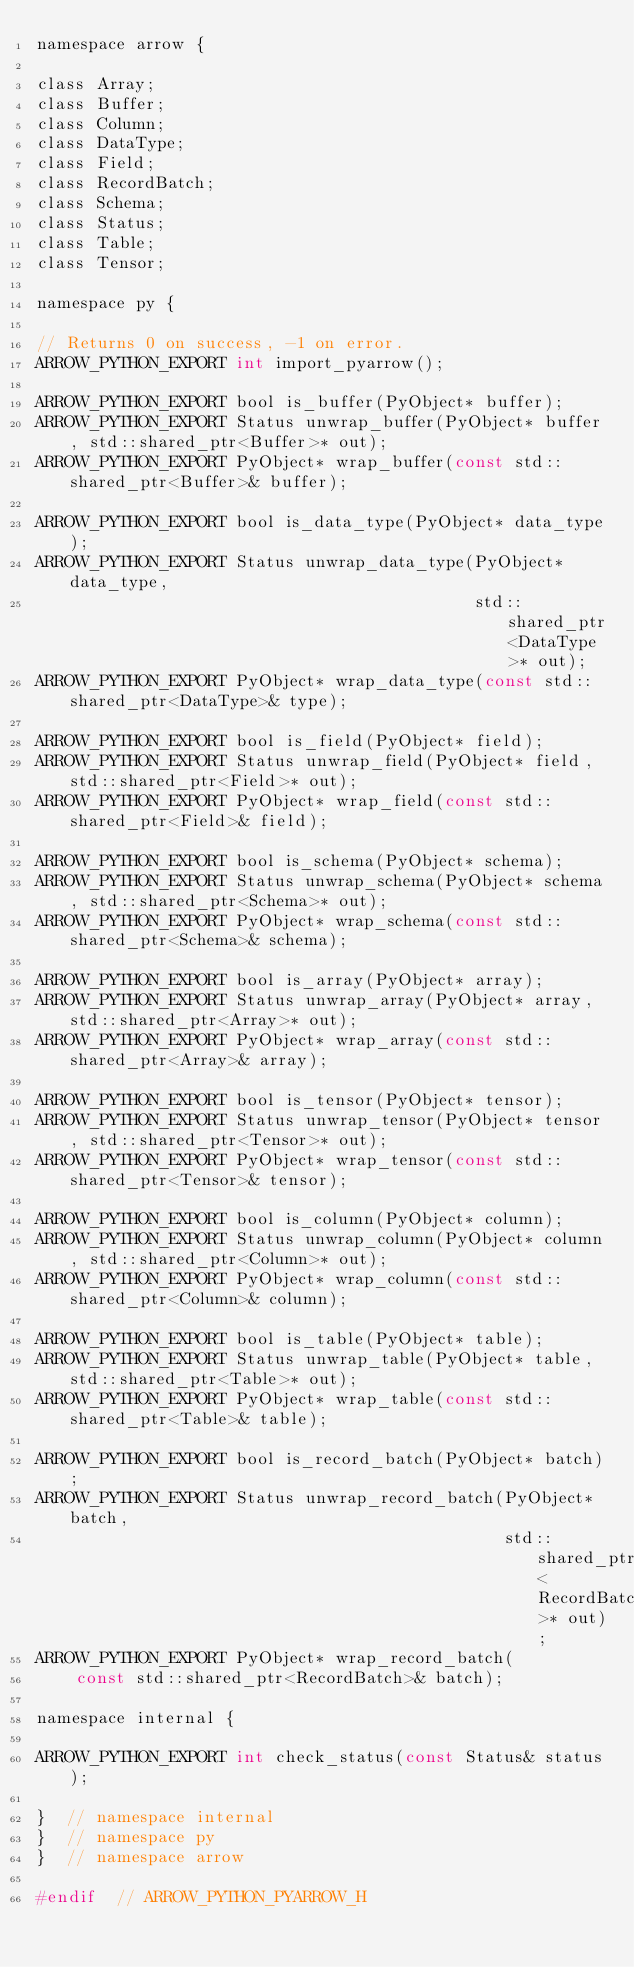<code> <loc_0><loc_0><loc_500><loc_500><_C_>namespace arrow {

class Array;
class Buffer;
class Column;
class DataType;
class Field;
class RecordBatch;
class Schema;
class Status;
class Table;
class Tensor;

namespace py {

// Returns 0 on success, -1 on error.
ARROW_PYTHON_EXPORT int import_pyarrow();

ARROW_PYTHON_EXPORT bool is_buffer(PyObject* buffer);
ARROW_PYTHON_EXPORT Status unwrap_buffer(PyObject* buffer, std::shared_ptr<Buffer>* out);
ARROW_PYTHON_EXPORT PyObject* wrap_buffer(const std::shared_ptr<Buffer>& buffer);

ARROW_PYTHON_EXPORT bool is_data_type(PyObject* data_type);
ARROW_PYTHON_EXPORT Status unwrap_data_type(PyObject* data_type,
                                            std::shared_ptr<DataType>* out);
ARROW_PYTHON_EXPORT PyObject* wrap_data_type(const std::shared_ptr<DataType>& type);

ARROW_PYTHON_EXPORT bool is_field(PyObject* field);
ARROW_PYTHON_EXPORT Status unwrap_field(PyObject* field, std::shared_ptr<Field>* out);
ARROW_PYTHON_EXPORT PyObject* wrap_field(const std::shared_ptr<Field>& field);

ARROW_PYTHON_EXPORT bool is_schema(PyObject* schema);
ARROW_PYTHON_EXPORT Status unwrap_schema(PyObject* schema, std::shared_ptr<Schema>* out);
ARROW_PYTHON_EXPORT PyObject* wrap_schema(const std::shared_ptr<Schema>& schema);

ARROW_PYTHON_EXPORT bool is_array(PyObject* array);
ARROW_PYTHON_EXPORT Status unwrap_array(PyObject* array, std::shared_ptr<Array>* out);
ARROW_PYTHON_EXPORT PyObject* wrap_array(const std::shared_ptr<Array>& array);

ARROW_PYTHON_EXPORT bool is_tensor(PyObject* tensor);
ARROW_PYTHON_EXPORT Status unwrap_tensor(PyObject* tensor, std::shared_ptr<Tensor>* out);
ARROW_PYTHON_EXPORT PyObject* wrap_tensor(const std::shared_ptr<Tensor>& tensor);

ARROW_PYTHON_EXPORT bool is_column(PyObject* column);
ARROW_PYTHON_EXPORT Status unwrap_column(PyObject* column, std::shared_ptr<Column>* out);
ARROW_PYTHON_EXPORT PyObject* wrap_column(const std::shared_ptr<Column>& column);

ARROW_PYTHON_EXPORT bool is_table(PyObject* table);
ARROW_PYTHON_EXPORT Status unwrap_table(PyObject* table, std::shared_ptr<Table>* out);
ARROW_PYTHON_EXPORT PyObject* wrap_table(const std::shared_ptr<Table>& table);

ARROW_PYTHON_EXPORT bool is_record_batch(PyObject* batch);
ARROW_PYTHON_EXPORT Status unwrap_record_batch(PyObject* batch,
                                               std::shared_ptr<RecordBatch>* out);
ARROW_PYTHON_EXPORT PyObject* wrap_record_batch(
    const std::shared_ptr<RecordBatch>& batch);

namespace internal {

ARROW_PYTHON_EXPORT int check_status(const Status& status);

}  // namespace internal
}  // namespace py
}  // namespace arrow

#endif  // ARROW_PYTHON_PYARROW_H
</code> 